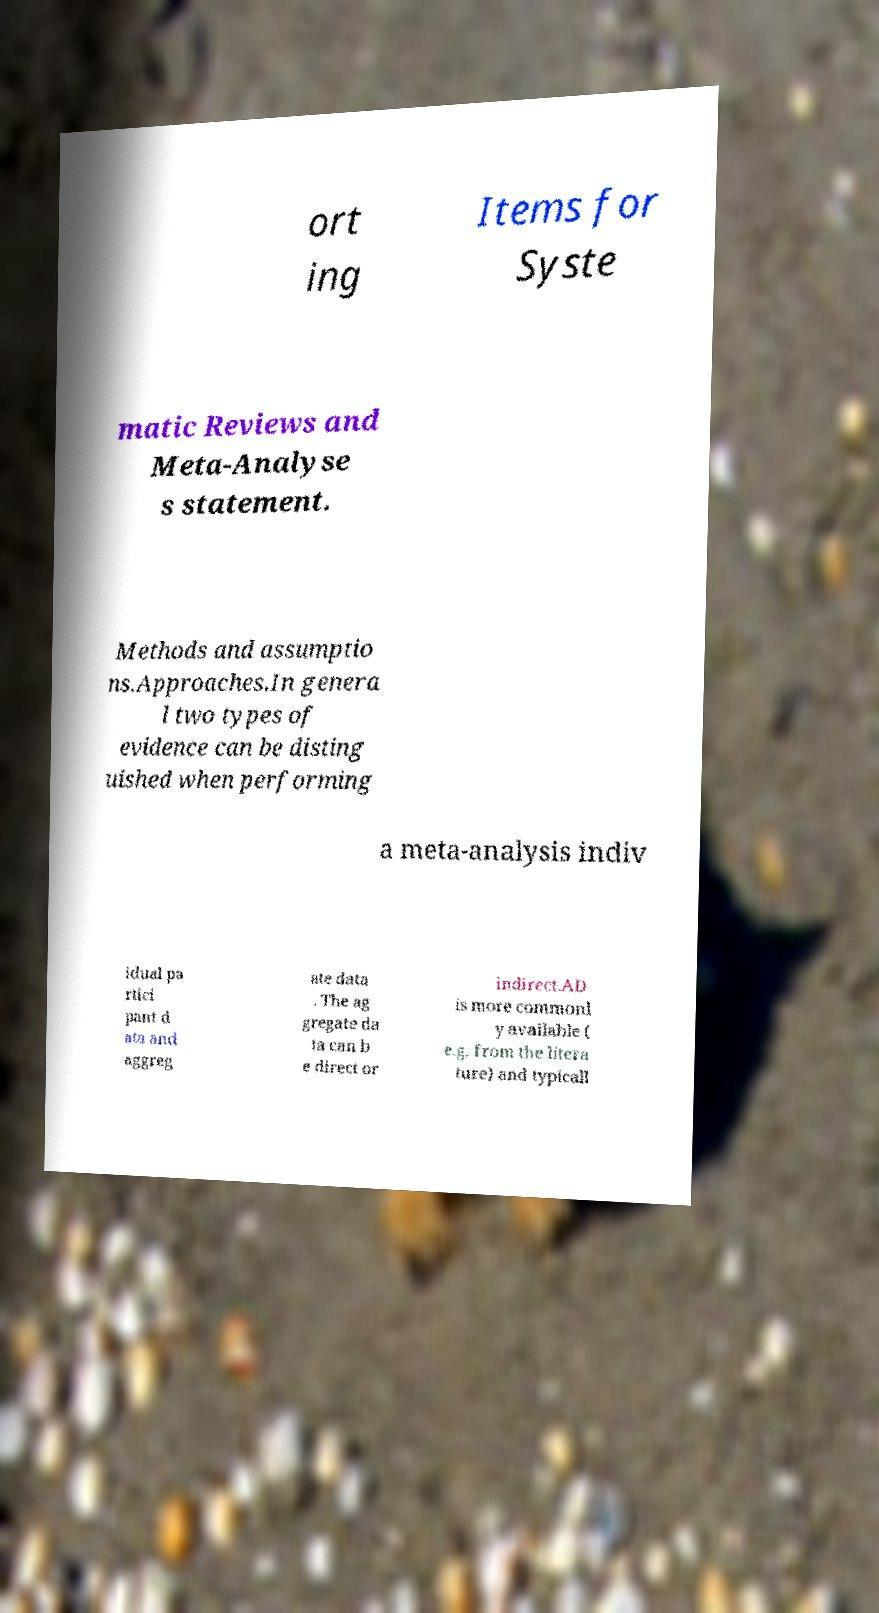What messages or text are displayed in this image? I need them in a readable, typed format. ort ing Items for Syste matic Reviews and Meta-Analyse s statement. Methods and assumptio ns.Approaches.In genera l two types of evidence can be disting uished when performing a meta-analysis indiv idual pa rtici pant d ata and aggreg ate data . The ag gregate da ta can b e direct or indirect.AD is more commonl y available ( e.g. from the litera ture) and typicall 